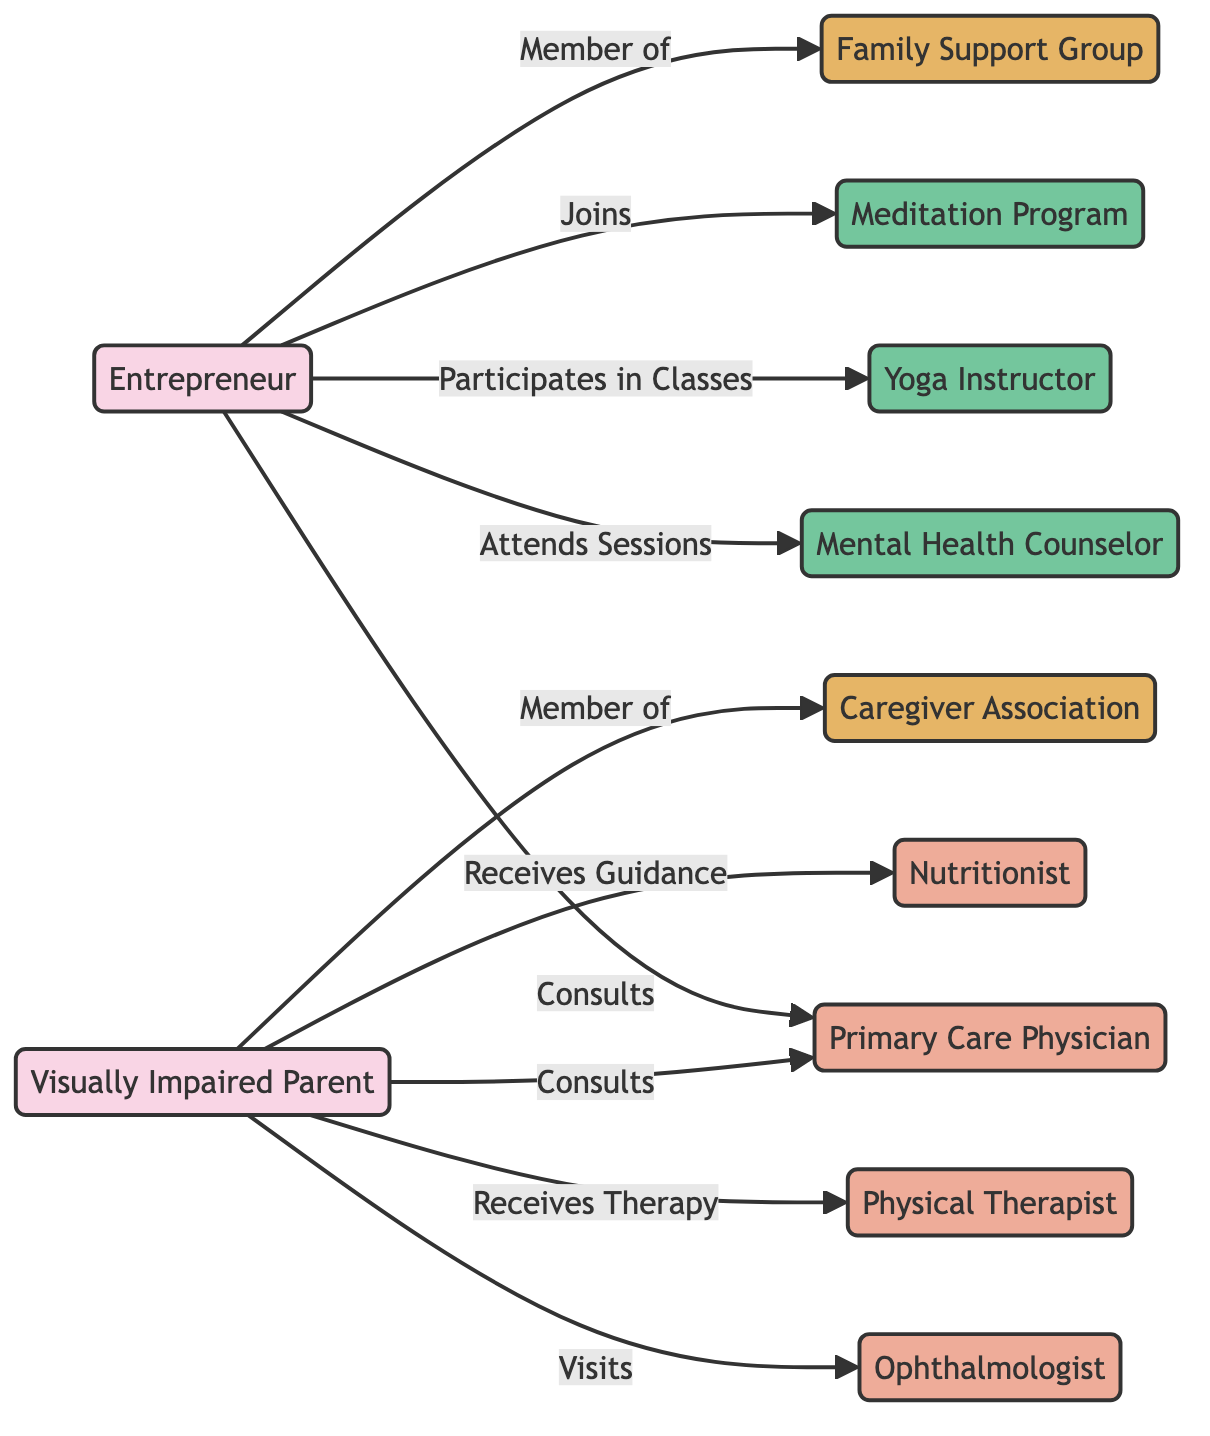What is the total number of nodes in the diagram? The diagram contains nodes representing different entities. By counting each unique node, we see there are 11 nodes in total: 2 persons, 4 healthcare providers, 2 support groups, and 3 wellness programs.
Answer: 11 Who does the entrepreneur consult with? In the diagram, the entrepreneur is directly linked to the primary care physician with the relationship labeled "Consults." This indicates that the entrepreneur seeks advice or assistance from this healthcare provider.
Answer: Primary Care Physician How many wellness programs are available in the network? By examining the nodes, we can see that there are three nodes labeled as wellness programs: Mental Health Counselor, Yoga Instructor, and Meditation Program. These represent different forms of support that focus on health and wellness.
Answer: 3 What type of relationship exists between the parent and the ophthalmologist? The relationship marked between the parent and the ophthalmologist is labeled "Visits." This implies that the parent goes to see this specialist for care related to their vision impairment.
Answer: Visits Which support group is the entrepreneur a member of? The entrepreneur is linked to the Family Support Group with the relationship labeled "Member of." This signifies their involvement and support connection within that group.
Answer: Family Support Group How many healthcare providers does the parent have connections with in the diagram? The parent has connections with four healthcare providers: Primary Care Physician, Ophthalmologist, Physical Therapist, and Nutritionist. Each of these connections indicates the parent’s various health-related consultations and services they receive.
Answer: 4 What is the connection between the parent and the caregiver association? The relationship between the parent and the caregiver association is labeled "Member of," indicating that the parent is a participant in this support group designed for caregivers.
Answer: Member of Who provides therapy to the parent? In the diagram, the parent is linked to the Physical Therapist, with the relationship labeled "Receives Therapy." This clearly states that the parent is receiving therapeutic services from this healthcare provider.
Answer: Physical Therapist What is the relationship between the entrepreneur and the mental health counselor? The entrepreneur is connected to the mental health counselor with the relationship labeled "Attends Sessions." This indicates that the entrepreneur actively participates in sessions with this wellness provider for mental health support.
Answer: Attends Sessions 